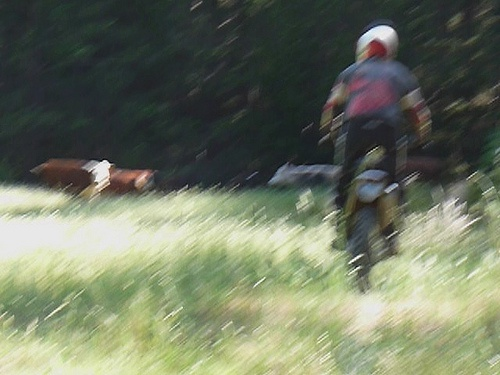Describe the objects in this image and their specific colors. I can see people in black, gray, and maroon tones, motorcycle in black, gray, darkgreen, and darkgray tones, cow in black, gray, and lightgray tones, cow in black and gray tones, and cow in black, gray, and maroon tones in this image. 